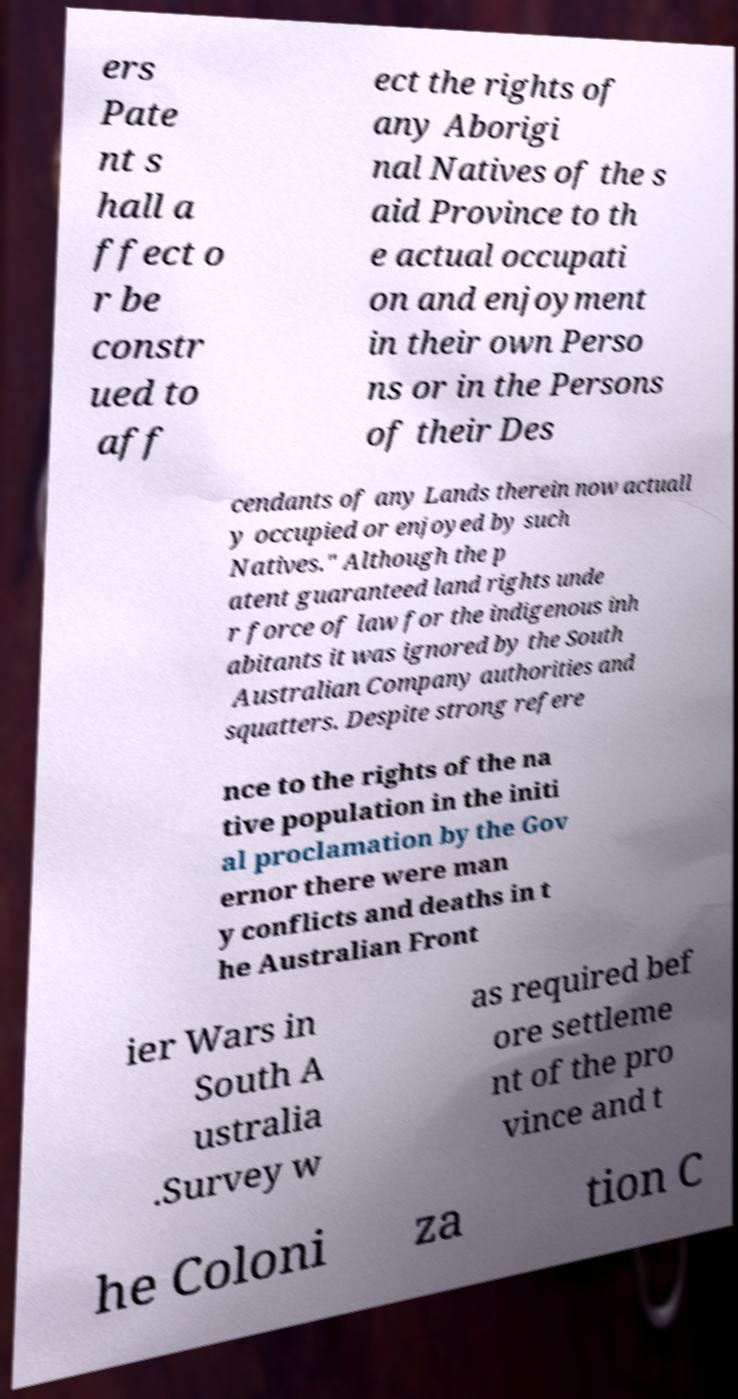Please read and relay the text visible in this image. What does it say? ers Pate nt s hall a ffect o r be constr ued to aff ect the rights of any Aborigi nal Natives of the s aid Province to th e actual occupati on and enjoyment in their own Perso ns or in the Persons of their Des cendants of any Lands therein now actuall y occupied or enjoyed by such Natives." Although the p atent guaranteed land rights unde r force of law for the indigenous inh abitants it was ignored by the South Australian Company authorities and squatters. Despite strong refere nce to the rights of the na tive population in the initi al proclamation by the Gov ernor there were man y conflicts and deaths in t he Australian Front ier Wars in South A ustralia .Survey w as required bef ore settleme nt of the pro vince and t he Coloni za tion C 